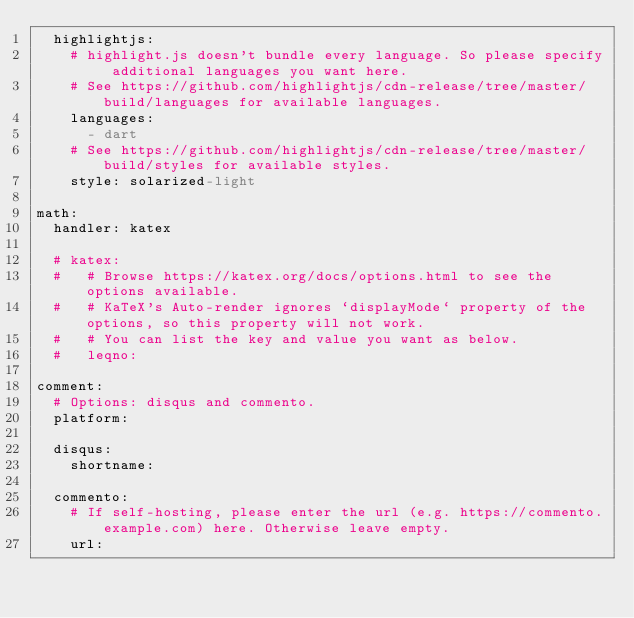Convert code to text. <code><loc_0><loc_0><loc_500><loc_500><_YAML_>  highlightjs:
    # highlight.js doesn't bundle every language. So please specify additional languages you want here.
    # See https://github.com/highlightjs/cdn-release/tree/master/build/languages for available languages.
    languages:
      - dart
    # See https://github.com/highlightjs/cdn-release/tree/master/build/styles for available styles.
    style: solarized-light

math:
  handler: katex

  # katex:
  #   # Browse https://katex.org/docs/options.html to see the options available.
  #   # KaTeX's Auto-render ignores `displayMode` property of the options, so this property will not work.
  #   # You can list the key and value you want as below.
  #   leqno:

comment:
  # Options: disqus and commento.
  platform:

  disqus:
    shortname:

  commento:
    # If self-hosting, please enter the url (e.g. https://commento.example.com) here. Otherwise leave empty.
    url:</code> 